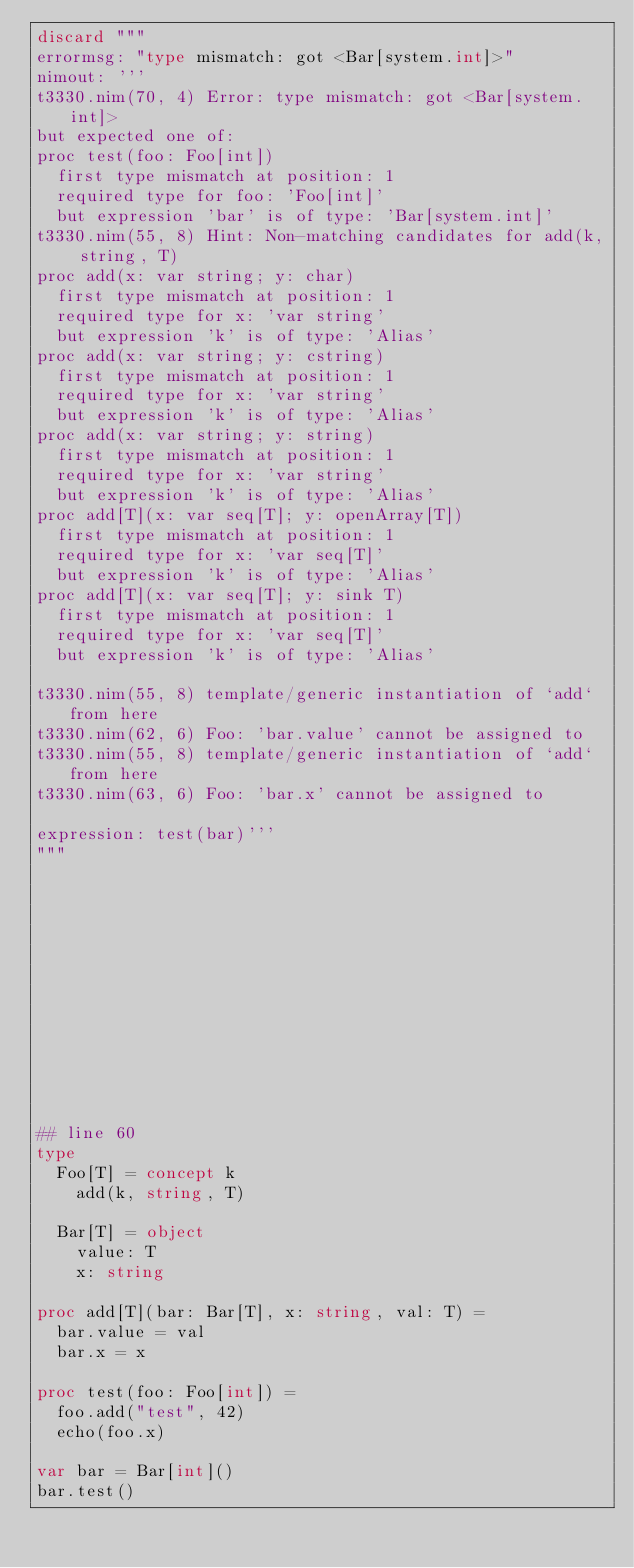<code> <loc_0><loc_0><loc_500><loc_500><_Nim_>discard """
errormsg: "type mismatch: got <Bar[system.int]>"
nimout: '''
t3330.nim(70, 4) Error: type mismatch: got <Bar[system.int]>
but expected one of:
proc test(foo: Foo[int])
  first type mismatch at position: 1
  required type for foo: 'Foo[int]'
  but expression 'bar' is of type: 'Bar[system.int]'
t3330.nim(55, 8) Hint: Non-matching candidates for add(k, string, T)
proc add(x: var string; y: char)
  first type mismatch at position: 1
  required type for x: 'var string'
  but expression 'k' is of type: 'Alias'
proc add(x: var string; y: cstring)
  first type mismatch at position: 1
  required type for x: 'var string'
  but expression 'k' is of type: 'Alias'
proc add(x: var string; y: string)
  first type mismatch at position: 1
  required type for x: 'var string'
  but expression 'k' is of type: 'Alias'
proc add[T](x: var seq[T]; y: openArray[T])
  first type mismatch at position: 1
  required type for x: 'var seq[T]'
  but expression 'k' is of type: 'Alias'
proc add[T](x: var seq[T]; y: sink T)
  first type mismatch at position: 1
  required type for x: 'var seq[T]'
  but expression 'k' is of type: 'Alias'

t3330.nim(55, 8) template/generic instantiation of `add` from here
t3330.nim(62, 6) Foo: 'bar.value' cannot be assigned to
t3330.nim(55, 8) template/generic instantiation of `add` from here
t3330.nim(63, 6) Foo: 'bar.x' cannot be assigned to

expression: test(bar)'''
"""













## line 60
type
  Foo[T] = concept k
    add(k, string, T)

  Bar[T] = object
    value: T
    x: string

proc add[T](bar: Bar[T], x: string, val: T) =
  bar.value = val
  bar.x = x

proc test(foo: Foo[int]) =
  foo.add("test", 42)
  echo(foo.x)

var bar = Bar[int]()
bar.test()
</code> 